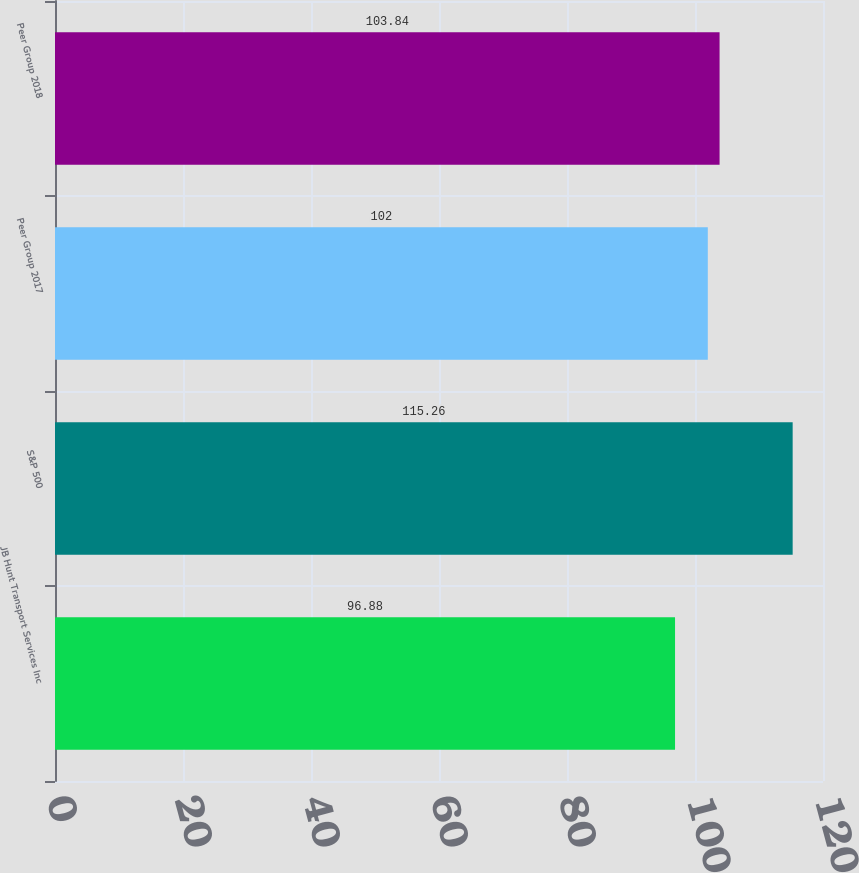<chart> <loc_0><loc_0><loc_500><loc_500><bar_chart><fcel>JB Hunt Transport Services Inc<fcel>S&P 500<fcel>Peer Group 2017<fcel>Peer Group 2018<nl><fcel>96.88<fcel>115.26<fcel>102<fcel>103.84<nl></chart> 